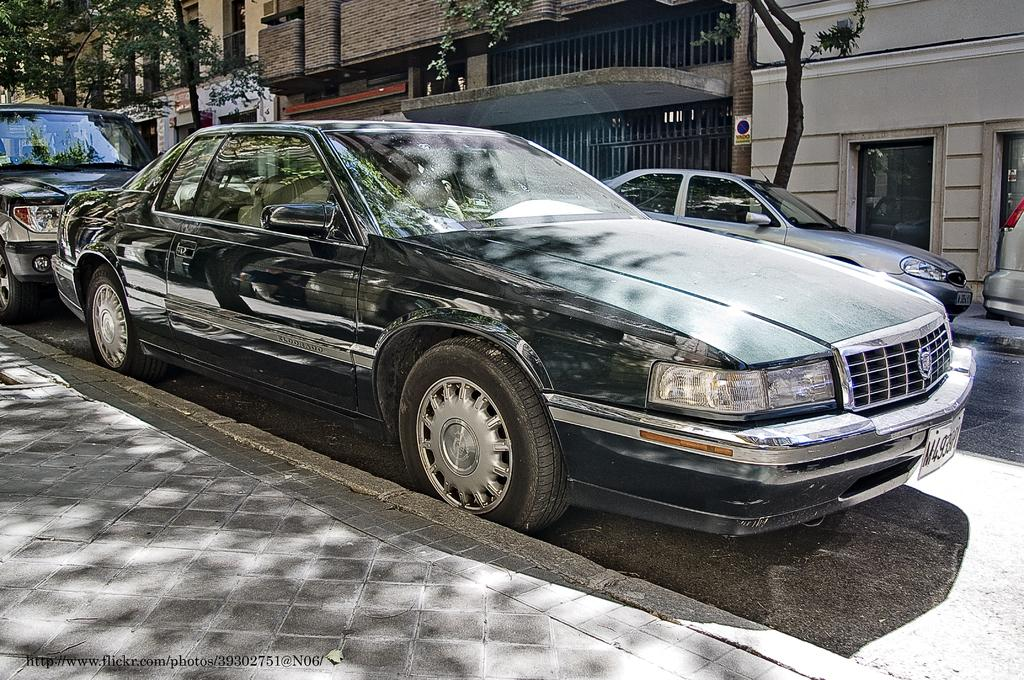What can be seen in the center of the image? In the center of the image, there are cars, buildings, trees, windows, a door, and grills. What is located at the bottom of the image? At the bottom of the image, there is a road and some text. How many eggs are being used to make the stamp in the image? There are no eggs or stamps present in the image. What type of crow can be seen interacting with the grills in the image? There is no crow present in the image; only cars, buildings, trees, windows, a door, and grills are visible in the center of the image. 